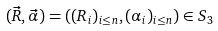Convert formula to latex. <formula><loc_0><loc_0><loc_500><loc_500>( \vec { R } , \vec { \alpha } ) = ( ( R _ { i } ) _ { i \leq n } , ( \alpha _ { i } ) _ { i \leq n } ) \in S _ { 3 }</formula> 